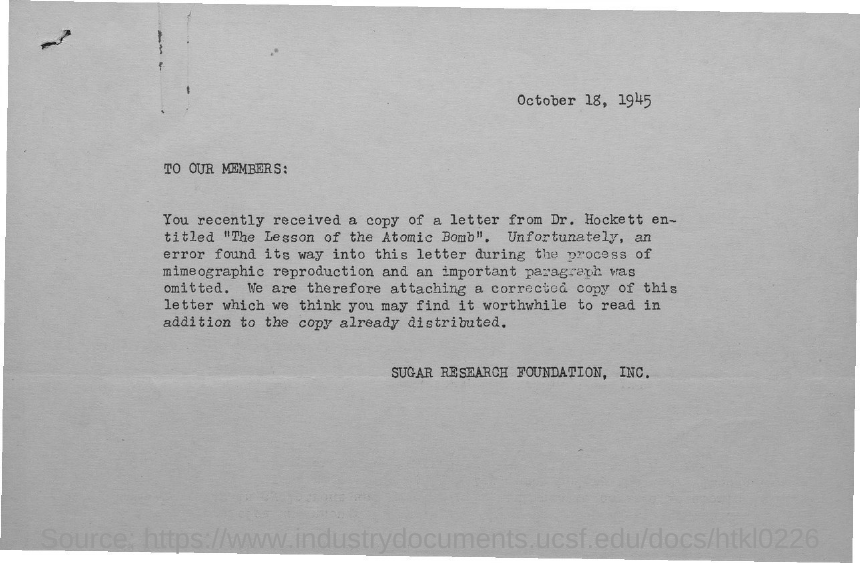What is the date mentioned in this document?
Offer a terse response. October 18, 1945. Who is the sender of this document?
Keep it short and to the point. SUGAR RESEARCH FOUNDATION, INC. 